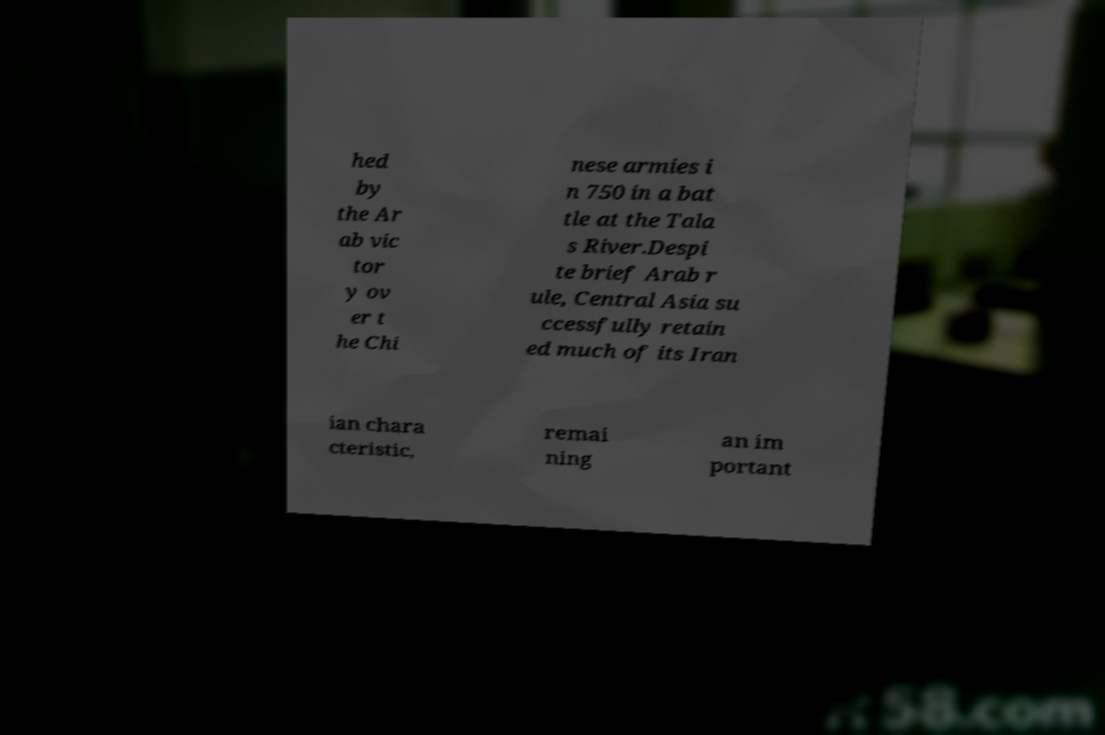Could you assist in decoding the text presented in this image and type it out clearly? hed by the Ar ab vic tor y ov er t he Chi nese armies i n 750 in a bat tle at the Tala s River.Despi te brief Arab r ule, Central Asia su ccessfully retain ed much of its Iran ian chara cteristic, remai ning an im portant 